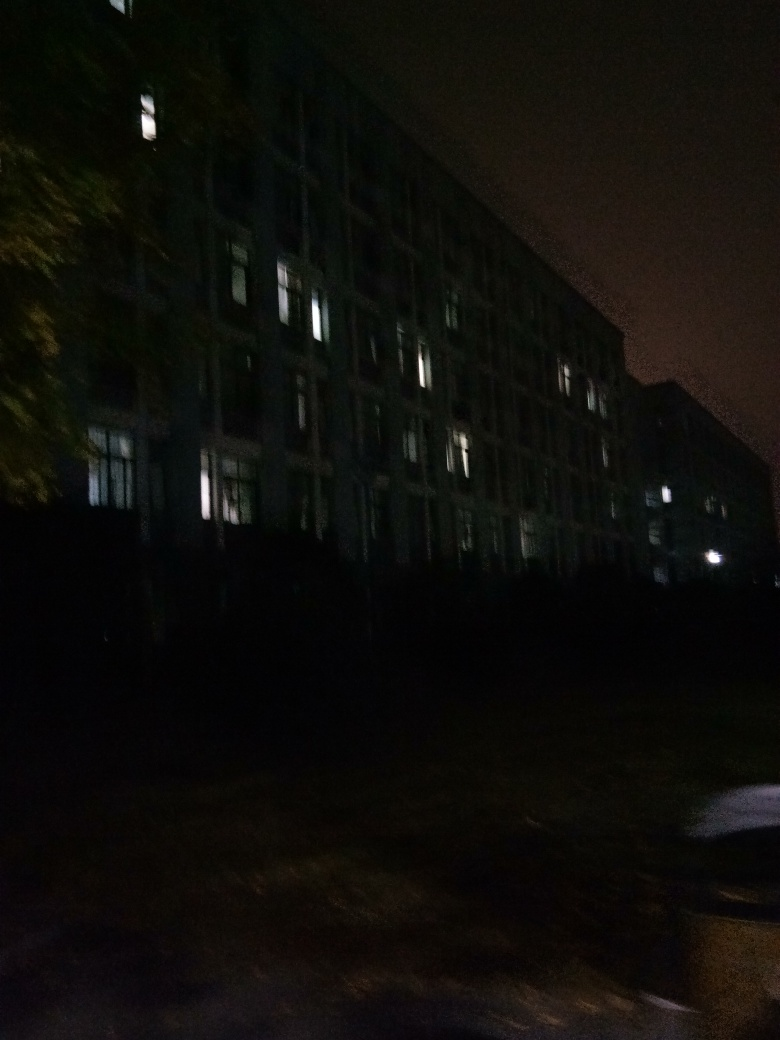How does the lighting affect the mood of this photograph? The dim and uneven lighting in the photograph provides a mysterious and suspenseful mood. The way certain windows are lit while others remain dark creates a contrast that can evoke feelings of isolation or curiosity about what is occurring inside the building. What time of day do you think the photo was taken? Given the darkness and the artificial light emanating from the windows, it's likely the photo was taken during the night. The absence of natural light contributes to the photo's enigmatic atmosphere. 